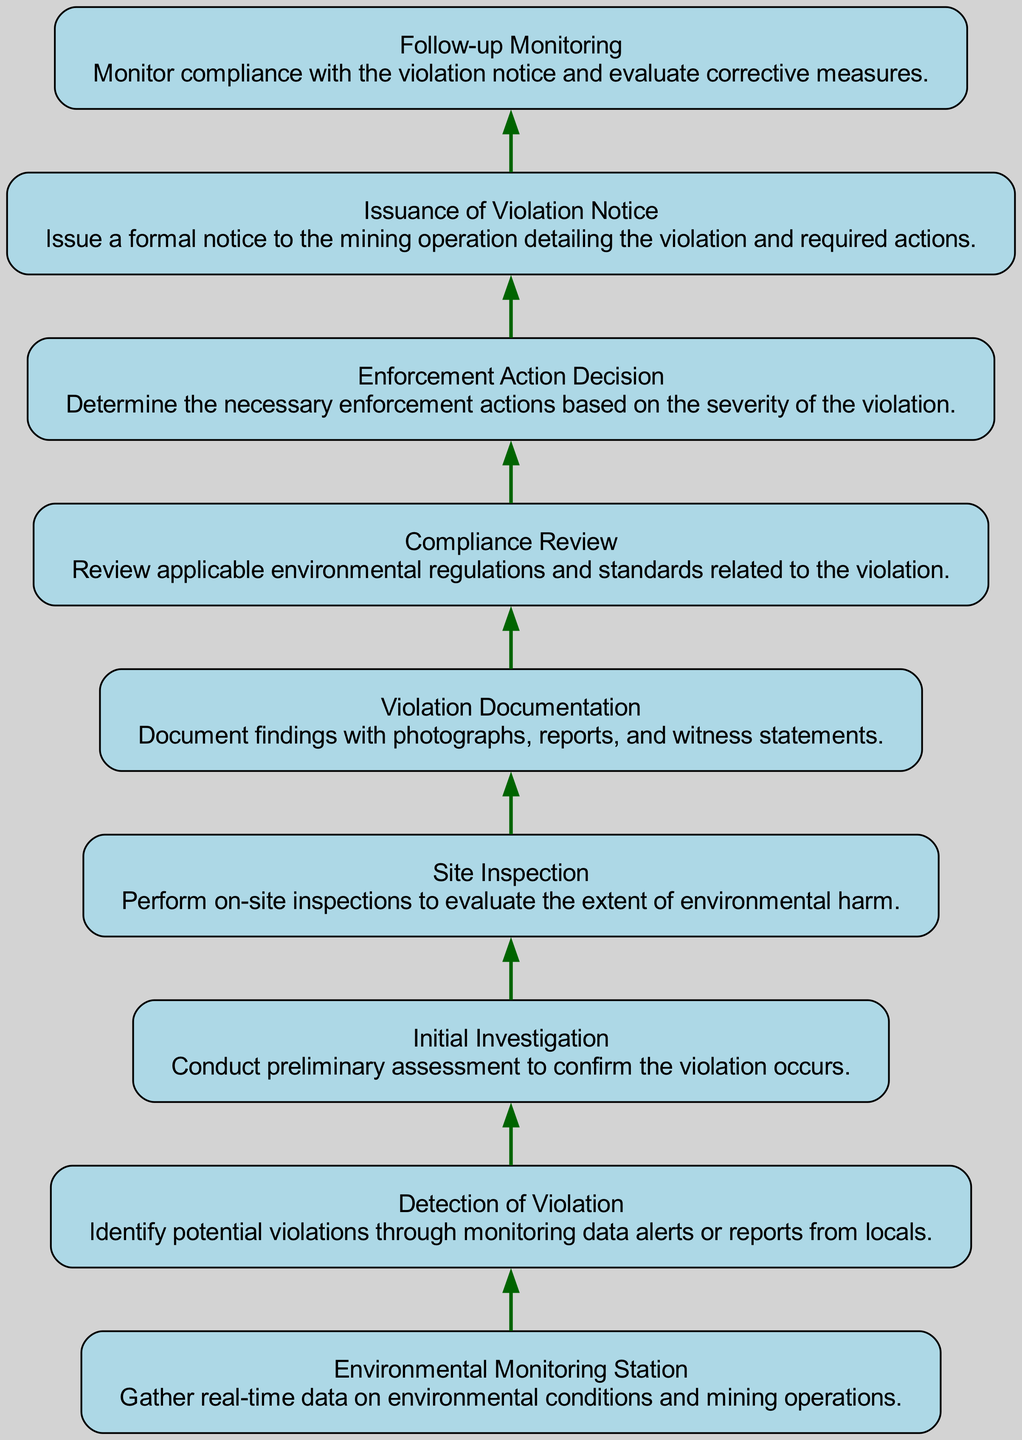What is the first step in the workflow? The first step identified in the diagram is labeled as "Environmental Monitoring Station." This is the starting point where real-time data on environmental conditions and mining operations is gathered.
Answer: Environmental Monitoring Station How many nodes are there in the flowchart? By counting each unique step/node listed in the flowchart, there are a total of nine nodes. These include the Environmental Monitoring Station, Detection of Violation, Initial Investigation, Site Inspection, Violation Documentation, Compliance Review, Enforcement Action Decision, Issuance of Violation Notice, and Follow-up Monitoring.
Answer: Nine What comes immediately after "Detection of Violation"? The flowchart indicates that after "Detection of Violation," the next step is "Initial Investigation." This signifies the step where a preliminary assessment is conducted to confirm whether the violation has occurred.
Answer: Initial Investigation Which node leads to "Issuance of Violation Notice"? From the diagram, the node leading directly to "Issuance of Violation Notice" is "Enforcement Action Decision." This indicates that a decision must be reached on the enforcement actions before the notice can be issued.
Answer: Enforcement Action Decision What action follows the "Site Inspection"? The action that follows "Site Inspection" in the workflow is "Violation Documentation," where findings from the inspection are documented with photographs and reports.
Answer: Violation Documentation What type of regulatory action can be determined at "Enforcement Action Decision"? At "Enforcement Action Decision," the necessary enforcement actions that depend on the severity of the violation will be determined. This is a critical node for defining regulatory responses.
Answer: Necessary enforcement actions Which step is focused on evaluating compliance after a violation notice? The step focused on evaluating compliance after a violation notice is "Follow-up Monitoring." This entails monitoring compliance and evaluating the corrective measures taken by the mining operation.
Answer: Follow-up Monitoring What is the primary function of the "Compliance Review"? The primary function of the "Compliance Review" is to review applicable environmental regulations and standards associated with the detected violation. This step ensures that the process aligns with legal requirements.
Answer: Review applicable regulations What are the end results from "Violation Documentation"? The end results from "Violation Documentation" include findings that are documented with photographs, reports, and witness statements. This step provides a record of the violation for further action.
Answer: Documented findings 